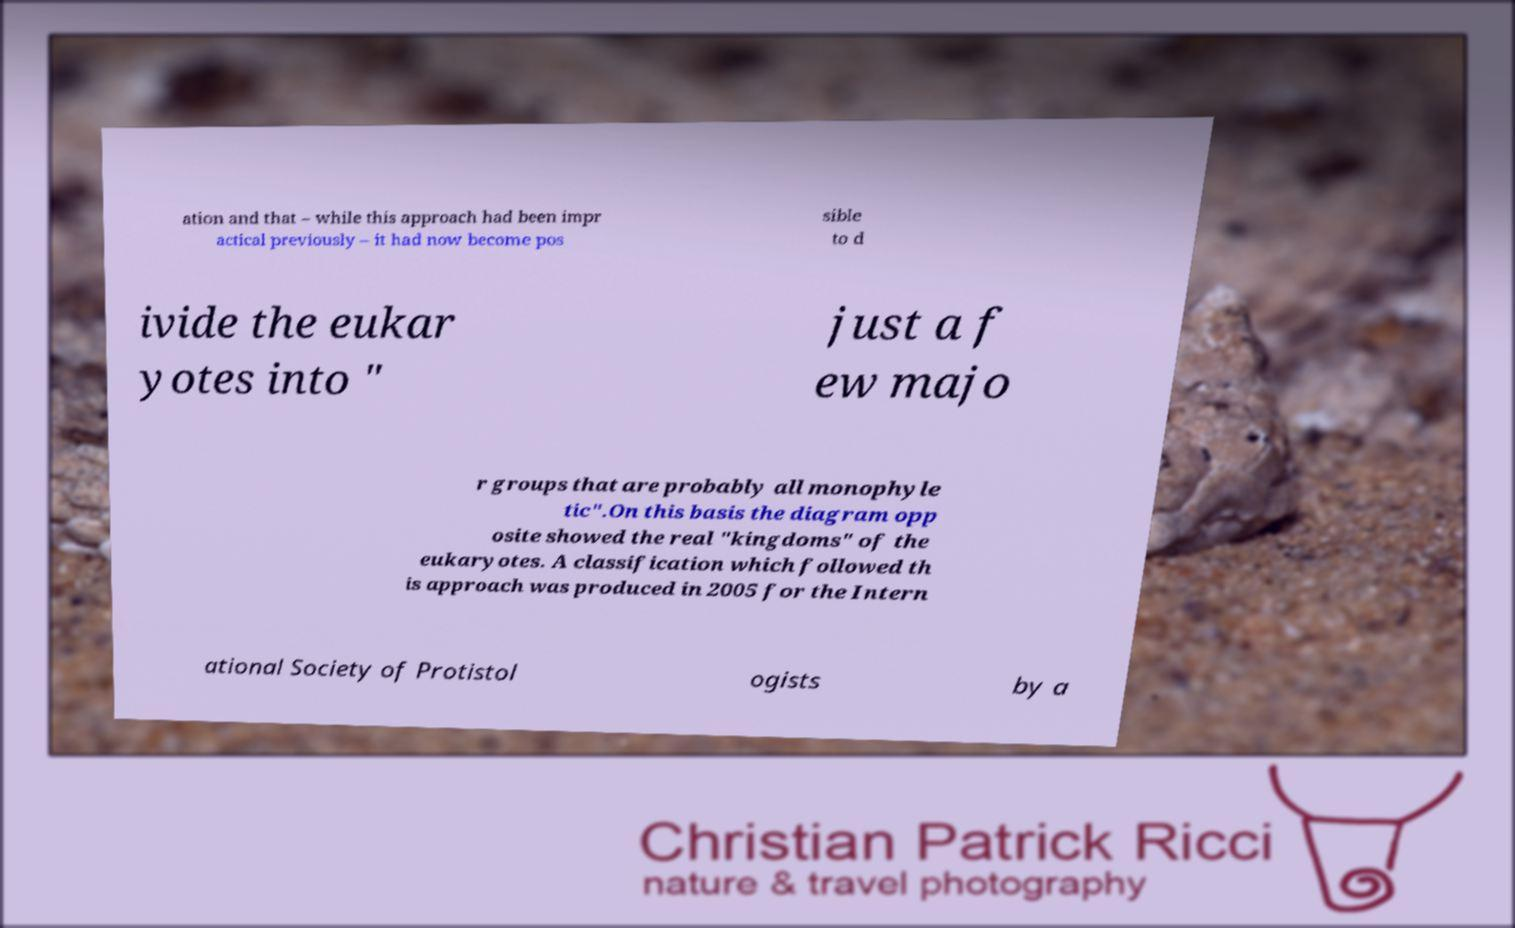Please identify and transcribe the text found in this image. ation and that – while this approach had been impr actical previously – it had now become pos sible to d ivide the eukar yotes into " just a f ew majo r groups that are probably all monophyle tic".On this basis the diagram opp osite showed the real "kingdoms" of the eukaryotes. A classification which followed th is approach was produced in 2005 for the Intern ational Society of Protistol ogists by a 